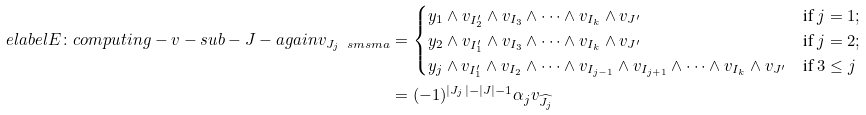Convert formula to latex. <formula><loc_0><loc_0><loc_500><loc_500>\ e l a b e l { E \colon c o m p u t i n g - v - s u b - J - a g a i n } v _ { J _ { j } \ s m s m a } & = \begin{cases} y _ { 1 } \wedge v _ { I _ { 2 } ^ { \prime } } \wedge v _ { I _ { 3 } } \wedge \dots \wedge v _ { I _ { k } } \wedge v _ { J ^ { \prime } } & \text {if } j = 1 ; \\ y _ { 2 } \wedge v _ { I _ { 1 } ^ { \prime } } \wedge v _ { I _ { 3 } } \wedge \dots \wedge v _ { I _ { k } } \wedge v _ { J ^ { \prime } } & \text {if } j = 2 ; \\ y _ { j } \wedge v _ { I _ { 1 } ^ { \prime } } \wedge v _ { I _ { 2 } } \wedge \dots \wedge v _ { I _ { j - 1 } } \wedge v _ { I _ { j + 1 } } \wedge \dots \wedge v _ { I _ { k } } \wedge v _ { J ^ { \prime } } & \text {if } 3 \leq j \end{cases} \\ & = ( - 1 ) ^ { | J _ { j } | - | J | - 1 } \alpha _ { j } v _ { \widehat { J _ { j } } }</formula> 